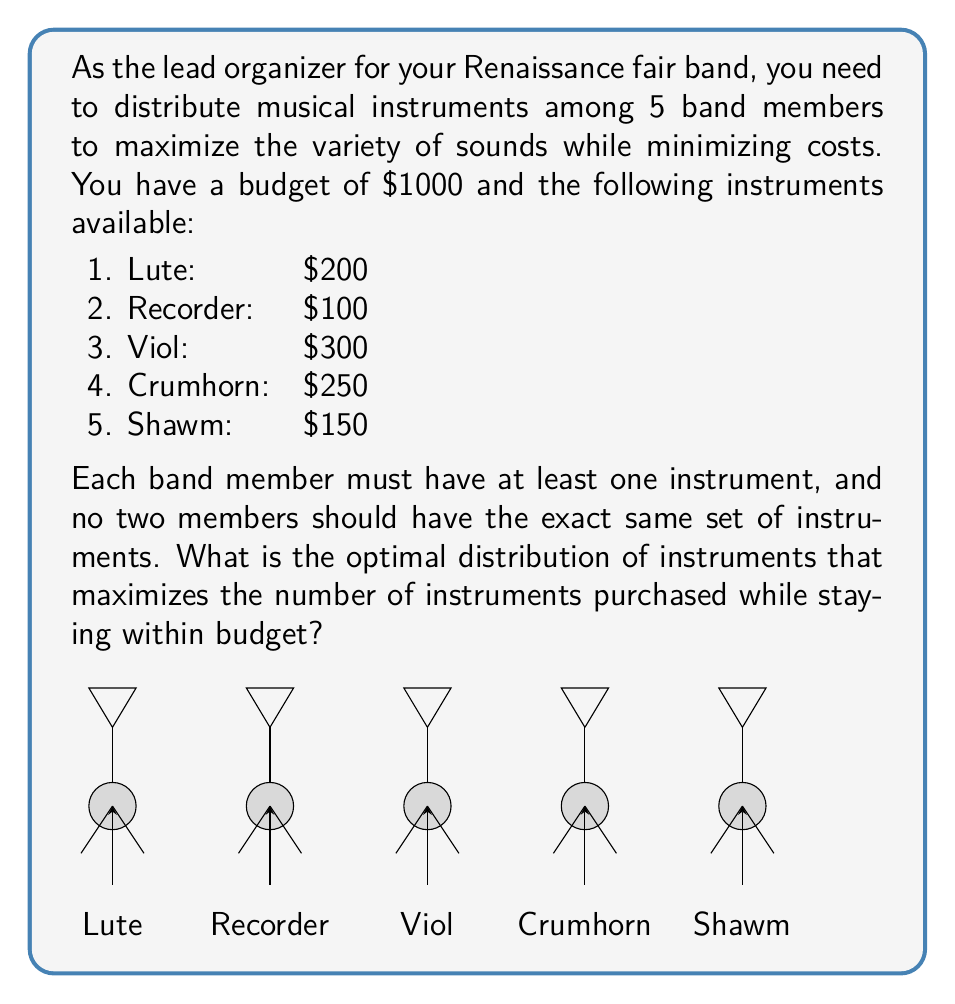Teach me how to tackle this problem. To solve this optimization problem, we'll use a greedy approach:

1) First, we'll sort the instruments by cost from lowest to highest:
   Recorder ($100), Shawm ($150), Lute ($200), Crumhorn ($250), Viol ($300)

2) We need to ensure each member has at least one instrument. Starting with the cheapest, we'll distribute one instrument to each member:
   5 * $100 (Recorder) = $500

3) We have $500 left in the budget. Let's continue distributing the next cheapest instruments:
   3 * $150 (Shawm) = $450
   Total so far: $950

4) We have $50 left, which is not enough for any more instruments.

5) Now, let's distribute these 8 instruments (5 Recorders and 3 Shawms) among the 5 members:

   Member 1: Recorder, Shawm
   Member 2: Recorder, Shawm
   Member 3: Recorder, Shawm
   Member 4: Recorder
   Member 5: Recorder

This distribution satisfies all constraints:
- Each member has at least one instrument
- No two members have the exact same set of instruments
- We've maximized the number of instruments (8) within the budget

The total cost is $950, which is within the $1000 budget.
Answer: Optimal distribution: 3 members with Recorder and Shawm, 2 members with only Recorder. 